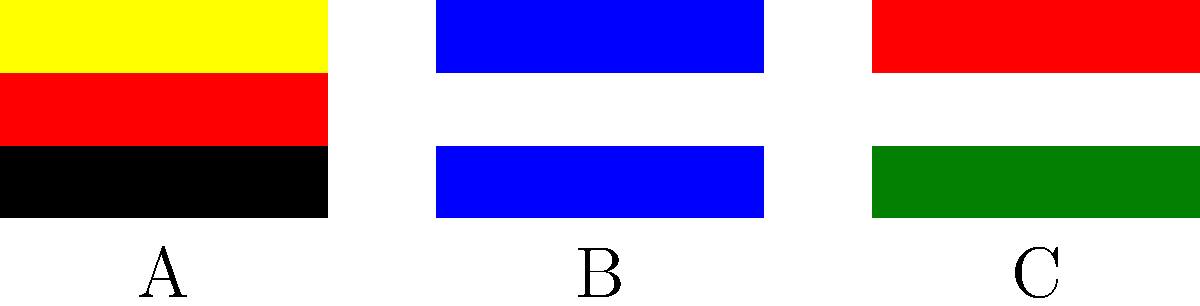In a diplomatic meeting involving representatives from Germany, Nicaragua, and Italy, which flag should be placed in the center position according to standard protocol, assuming alphabetical order in the local language (English) is used? To answer this question, we need to follow these steps:

1. Identify the flags in the image:
   A: Germany (black, red, gold horizontal stripes)
   B: Nicaragua (blue, white, blue horizontal stripes)
   C: Italy (green, white, red vertical stripes)

2. Understand the standard protocol:
   When multiple flags are displayed, the host country's flag is typically placed in the position of honor (usually the center). If the host country's flag is not present, alphabetical order in the local language is often used.

3. Apply alphabetical order in English:
   Germany
   Italy
   Nicaragua

4. Determine the center position:
   With three flags, the center position would be occupied by the second flag in alphabetical order.

5. Conclusion:
   Italy's flag should be placed in the center position.
Answer: Italy 